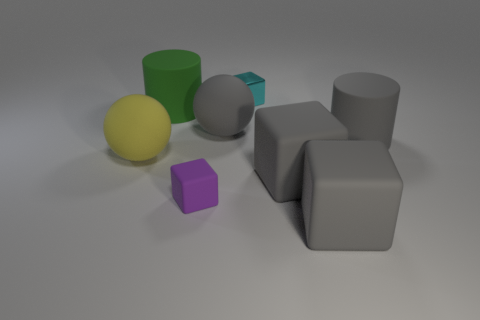There is a cylinder that is to the left of the small cyan block; is it the same size as the purple matte block in front of the big yellow matte ball?
Your response must be concise. No. What shape is the large gray matte object behind the rubber cylinder that is right of the small cyan metal cube?
Ensure brevity in your answer.  Sphere. How many purple cubes are the same size as the cyan metal object?
Give a very brief answer. 1. Is there a green matte thing?
Give a very brief answer. Yes. Is there anything else that has the same color as the small shiny object?
Keep it short and to the point. No. What shape is the yellow object that is made of the same material as the tiny purple block?
Make the answer very short. Sphere. The big cylinder to the right of the big rubber cube that is in front of the rubber cube that is to the left of the tiny cyan shiny thing is what color?
Offer a very short reply. Gray. Are there an equal number of metal objects that are to the left of the cyan metallic object and small cyan shiny cubes?
Keep it short and to the point. No. Are there any other things that have the same material as the large green cylinder?
Provide a short and direct response. Yes. There is a metal block; is its color the same as the rubber thing in front of the purple block?
Give a very brief answer. No. 